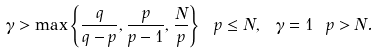<formula> <loc_0><loc_0><loc_500><loc_500>\gamma > \max \left \{ \frac { q } { q - p } , \frac { p } { p - 1 } , \frac { N } { p } \right \} \ p \leq N , \ \gamma = 1 \ p > N .</formula> 